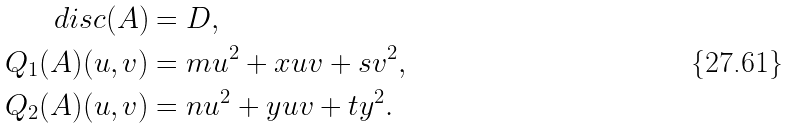<formula> <loc_0><loc_0><loc_500><loc_500>d i s c ( A ) & = D , \\ Q _ { 1 } ( A ) ( u , v ) & = m u ^ { 2 } + x u v + s v ^ { 2 } , \\ Q _ { 2 } ( A ) ( u , v ) & = n u ^ { 2 } + y u v + t y ^ { 2 } .</formula> 